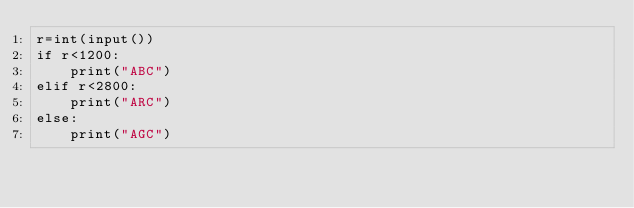<code> <loc_0><loc_0><loc_500><loc_500><_Python_>r=int(input())
if r<1200:
    print("ABC")
elif r<2800:
    print("ARC")
else:
    print("AGC")</code> 